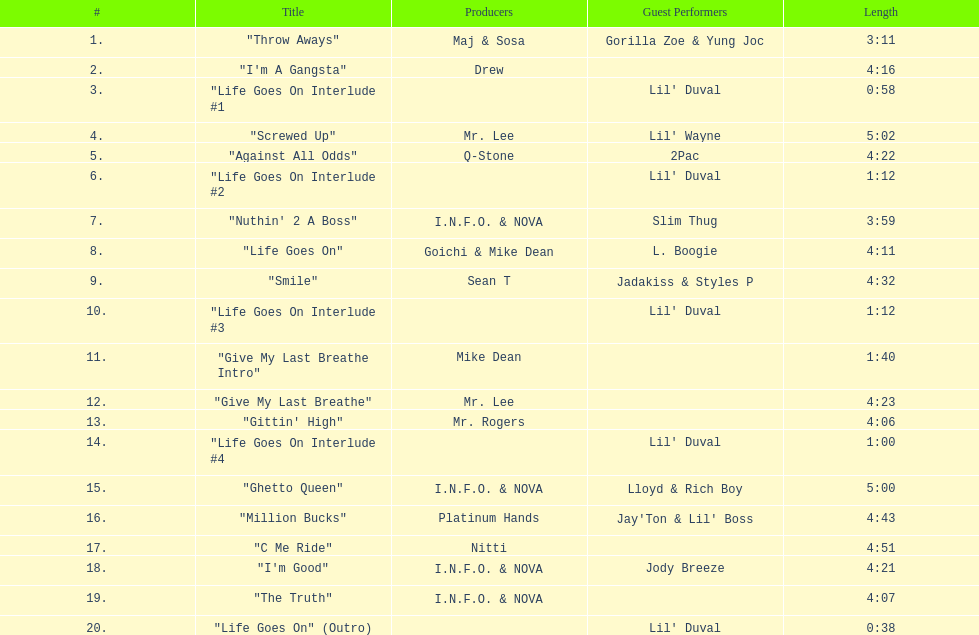Would you mind parsing the complete table? {'header': ['#', 'Title', 'Producers', 'Guest Performers', 'Length'], 'rows': [['1.', '"Throw Aways"', 'Maj & Sosa', 'Gorilla Zoe & Yung Joc', '3:11'], ['2.', '"I\'m A Gangsta"', 'Drew', '', '4:16'], ['3.', '"Life Goes On Interlude #1', '', "Lil' Duval", '0:58'], ['4.', '"Screwed Up"', 'Mr. Lee', "Lil' Wayne", '5:02'], ['5.', '"Against All Odds"', 'Q-Stone', '2Pac', '4:22'], ['6.', '"Life Goes On Interlude #2', '', "Lil' Duval", '1:12'], ['7.', '"Nuthin\' 2 A Boss"', 'I.N.F.O. & NOVA', 'Slim Thug', '3:59'], ['8.', '"Life Goes On"', 'Goichi & Mike Dean', 'L. Boogie', '4:11'], ['9.', '"Smile"', 'Sean T', 'Jadakiss & Styles P', '4:32'], ['10.', '"Life Goes On Interlude #3', '', "Lil' Duval", '1:12'], ['11.', '"Give My Last Breathe Intro"', 'Mike Dean', '', '1:40'], ['12.', '"Give My Last Breathe"', 'Mr. Lee', '', '4:23'], ['13.', '"Gittin\' High"', 'Mr. Rogers', '', '4:06'], ['14.', '"Life Goes On Interlude #4', '', "Lil' Duval", '1:00'], ['15.', '"Ghetto Queen"', 'I.N.F.O. & NOVA', 'Lloyd & Rich Boy', '5:00'], ['16.', '"Million Bucks"', 'Platinum Hands', "Jay'Ton & Lil' Boss", '4:43'], ['17.', '"C Me Ride"', 'Nitti', '', '4:51'], ['18.', '"I\'m Good"', 'I.N.F.O. & NOVA', 'Jody Breeze', '4:21'], ['19.', '"The Truth"', 'I.N.F.O. & NOVA', '', '4:07'], ['20.', '"Life Goes On" (Outro)', '', "Lil' Duval", '0:38']]} What's the overall count of tracks present on the album? 20. 